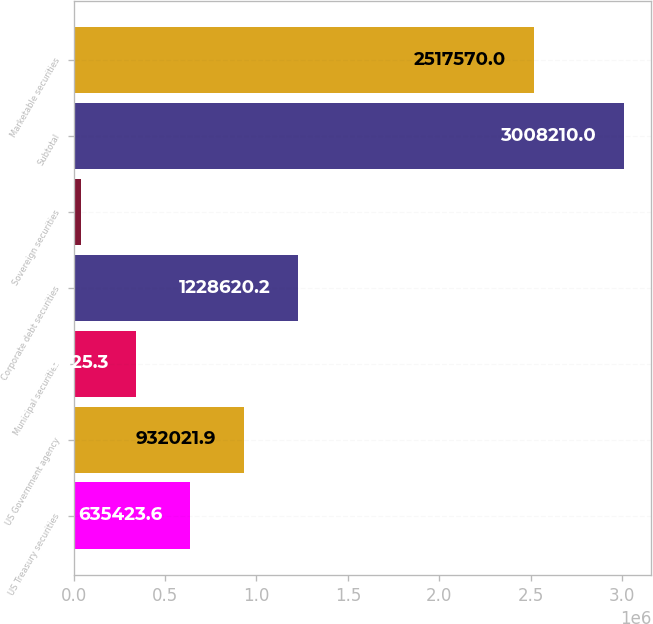<chart> <loc_0><loc_0><loc_500><loc_500><bar_chart><fcel>US Treasury securities<fcel>US Government agency<fcel>Municipal securities<fcel>Corporate debt securities<fcel>Sovereign securities<fcel>Subtotal<fcel>Marketable securities<nl><fcel>635424<fcel>932022<fcel>338825<fcel>1.22862e+06<fcel>42227<fcel>3.00821e+06<fcel>2.51757e+06<nl></chart> 